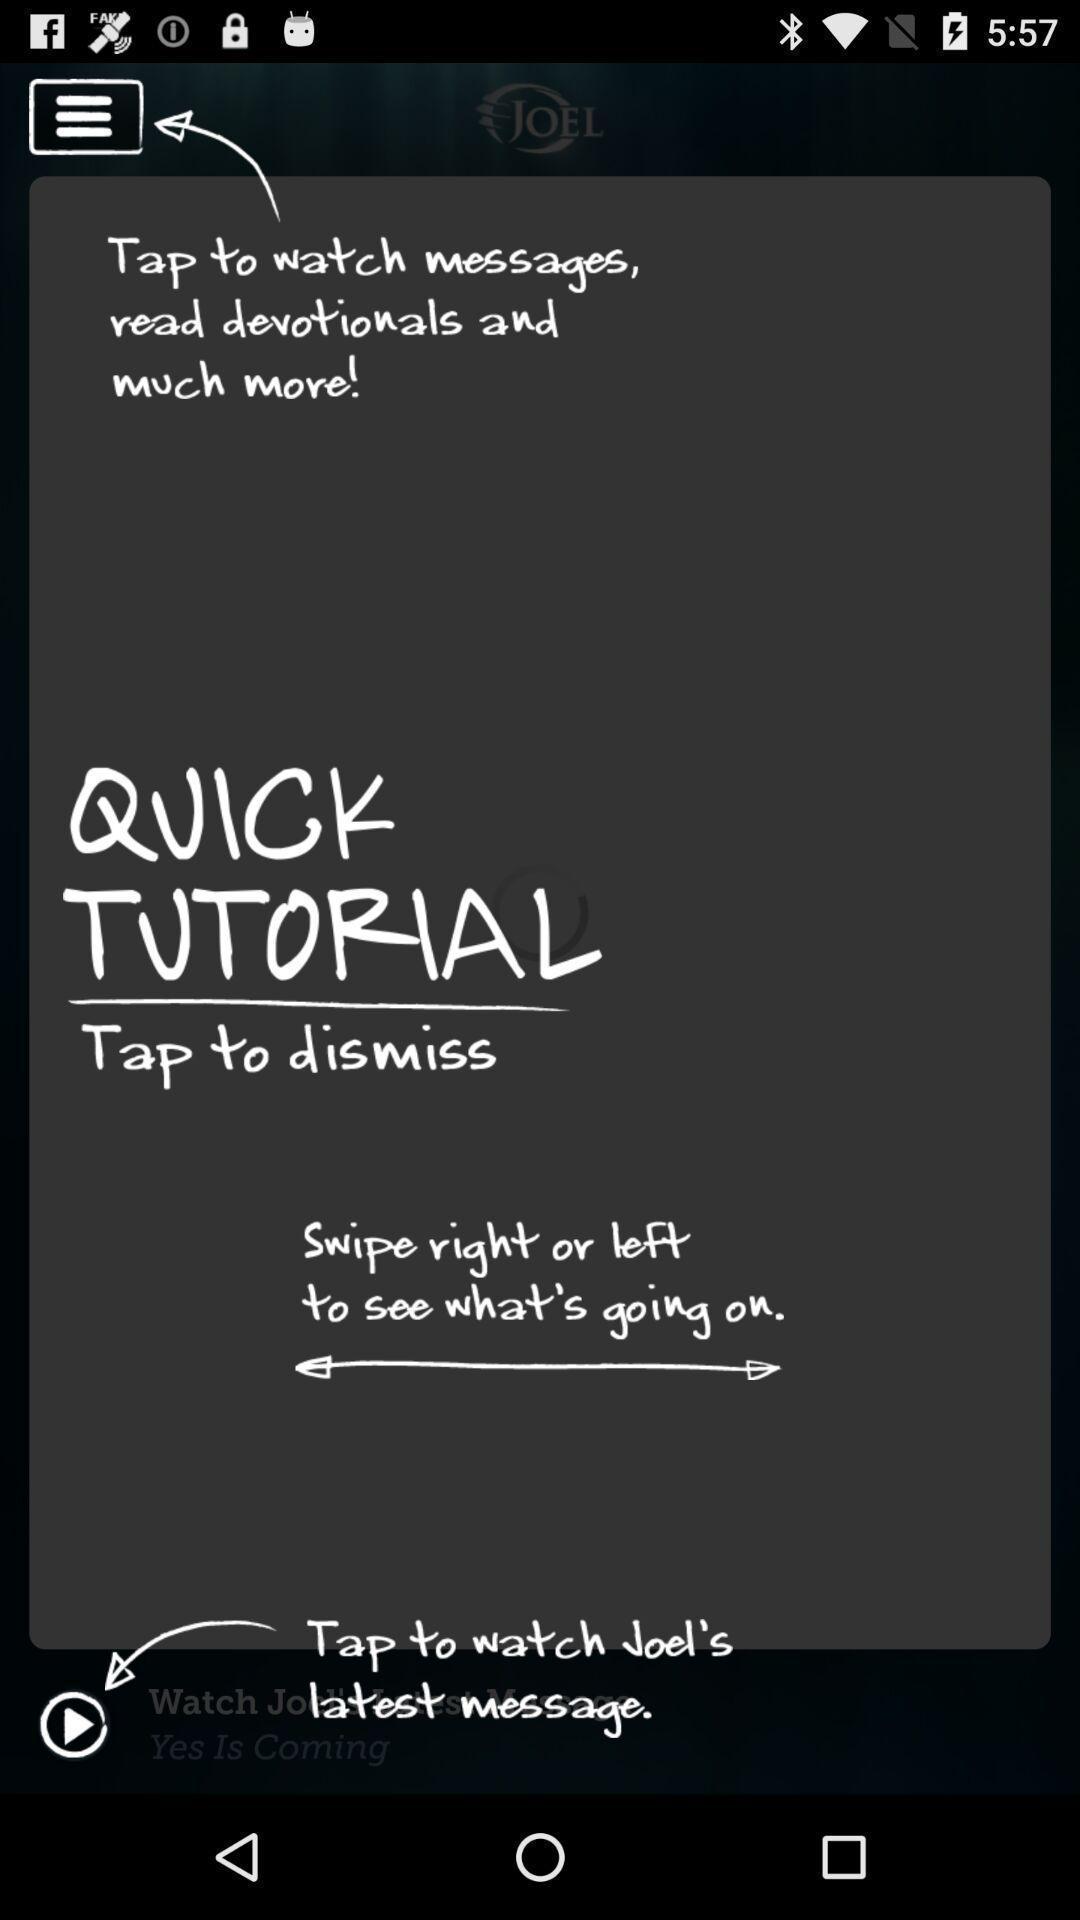Describe the content in this image. Page shows some text in an social application. 